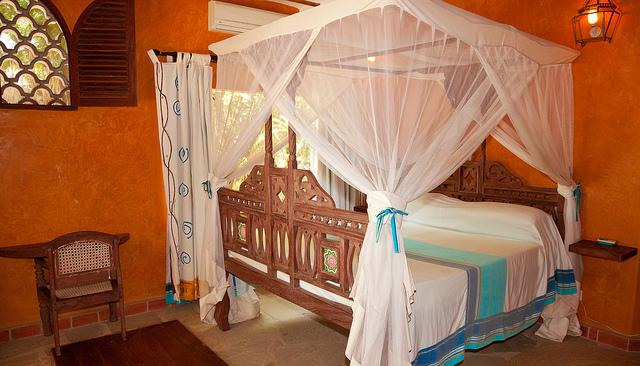The walls are most likely covered in what material? wallpaper 